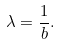Convert formula to latex. <formula><loc_0><loc_0><loc_500><loc_500>\lambda = \frac { 1 } { b } .</formula> 